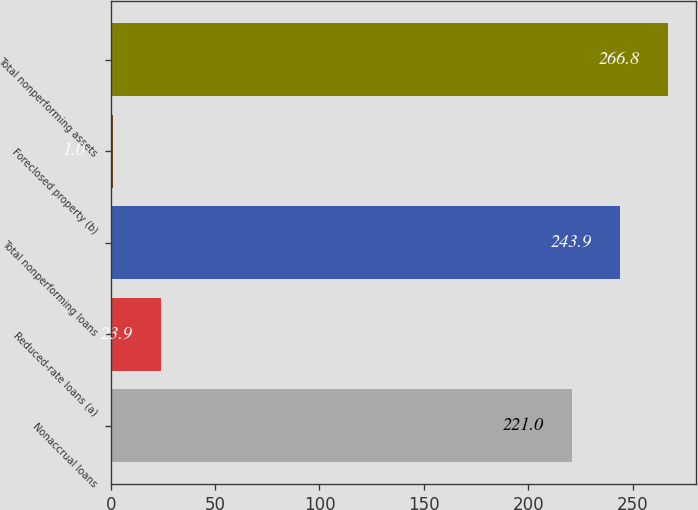Convert chart. <chart><loc_0><loc_0><loc_500><loc_500><bar_chart><fcel>Nonaccrual loans<fcel>Reduced-rate loans (a)<fcel>Total nonperforming loans<fcel>Foreclosed property (b)<fcel>Total nonperforming assets<nl><fcel>221<fcel>23.9<fcel>243.9<fcel>1<fcel>266.8<nl></chart> 